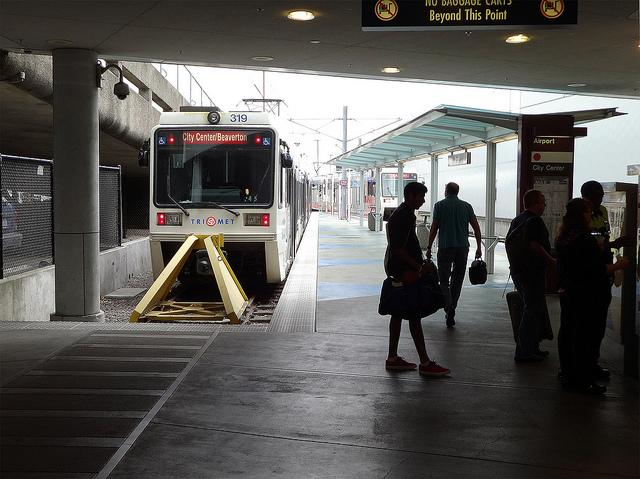The people carrying bags are doing so because of what reason? traveling 